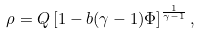<formula> <loc_0><loc_0><loc_500><loc_500>\rho = Q \left [ 1 - b ( \gamma - 1 ) \Phi \right ] ^ { \frac { 1 } { \gamma - 1 } } ,</formula> 